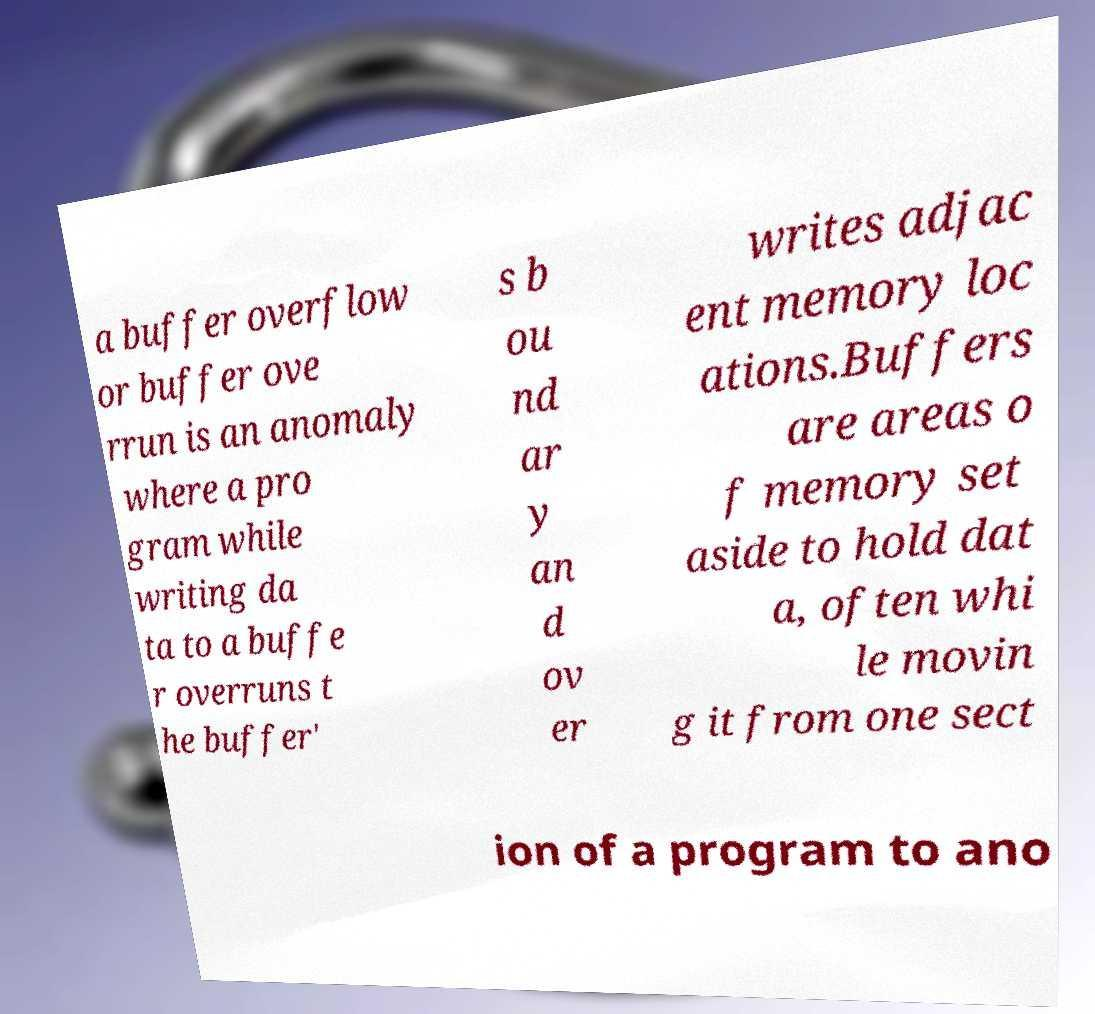Can you read and provide the text displayed in the image?This photo seems to have some interesting text. Can you extract and type it out for me? a buffer overflow or buffer ove rrun is an anomaly where a pro gram while writing da ta to a buffe r overruns t he buffer' s b ou nd ar y an d ov er writes adjac ent memory loc ations.Buffers are areas o f memory set aside to hold dat a, often whi le movin g it from one sect ion of a program to ano 